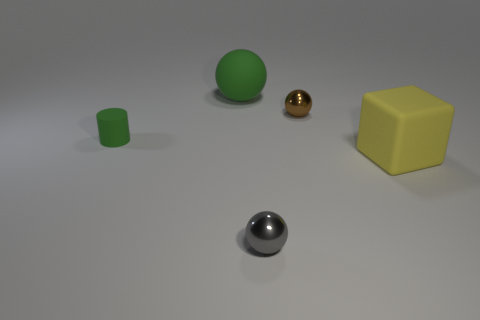Subtract all small metallic spheres. How many spheres are left? 1 Add 4 green rubber objects. How many objects exist? 9 Subtract all cubes. How many objects are left? 4 Subtract 1 spheres. How many spheres are left? 2 Subtract all brown blocks. Subtract all purple spheres. How many blocks are left? 1 Subtract all tiny spheres. Subtract all yellow rubber objects. How many objects are left? 2 Add 1 tiny cylinders. How many tiny cylinders are left? 2 Add 1 green cylinders. How many green cylinders exist? 2 Subtract all gray spheres. How many spheres are left? 2 Subtract 0 cyan blocks. How many objects are left? 5 